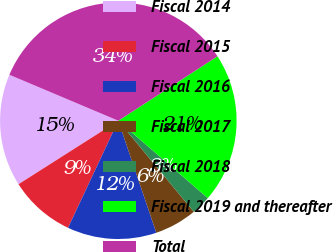Convert chart to OTSL. <chart><loc_0><loc_0><loc_500><loc_500><pie_chart><fcel>Fiscal 2014<fcel>Fiscal 2015<fcel>Fiscal 2016<fcel>Fiscal 2017<fcel>Fiscal 2018<fcel>Fiscal 2019 and thereafter<fcel>Total<nl><fcel>15.37%<fcel>9.0%<fcel>12.19%<fcel>5.82%<fcel>2.63%<fcel>20.52%<fcel>34.47%<nl></chart> 